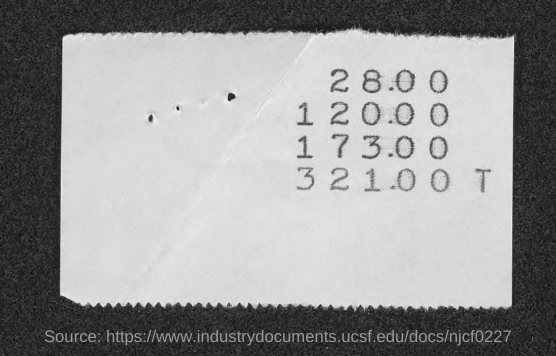What is the first amount given in the slip?
Offer a terse response. 28.00. What is the second amount mentioned in the slip?
Offer a very short reply. 120.00. 